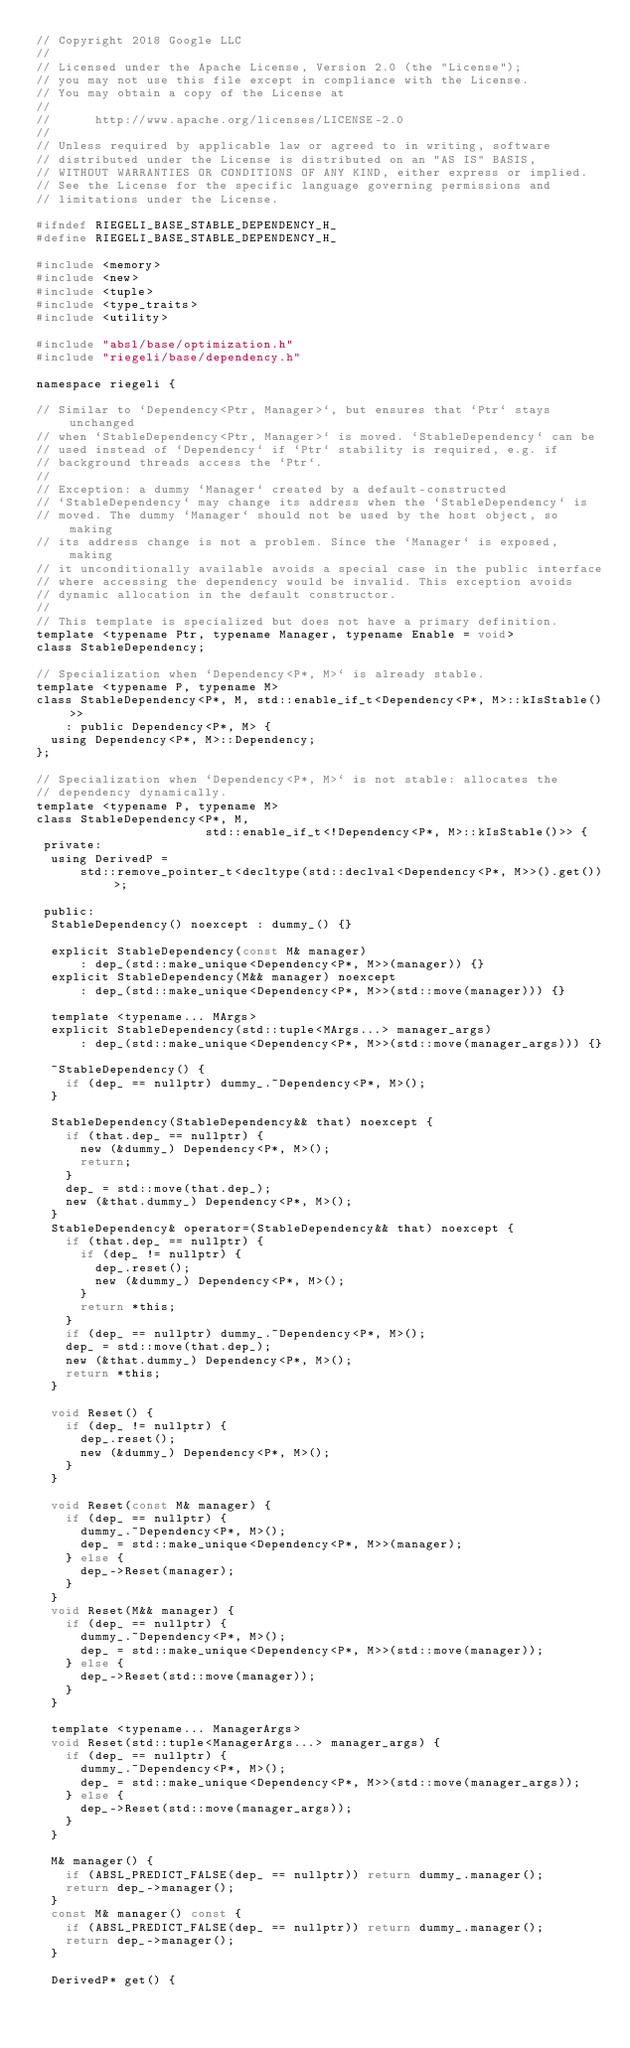Convert code to text. <code><loc_0><loc_0><loc_500><loc_500><_C_>// Copyright 2018 Google LLC
//
// Licensed under the Apache License, Version 2.0 (the "License");
// you may not use this file except in compliance with the License.
// You may obtain a copy of the License at
//
//      http://www.apache.org/licenses/LICENSE-2.0
//
// Unless required by applicable law or agreed to in writing, software
// distributed under the License is distributed on an "AS IS" BASIS,
// WITHOUT WARRANTIES OR CONDITIONS OF ANY KIND, either express or implied.
// See the License for the specific language governing permissions and
// limitations under the License.

#ifndef RIEGELI_BASE_STABLE_DEPENDENCY_H_
#define RIEGELI_BASE_STABLE_DEPENDENCY_H_

#include <memory>
#include <new>
#include <tuple>
#include <type_traits>
#include <utility>

#include "absl/base/optimization.h"
#include "riegeli/base/dependency.h"

namespace riegeli {

// Similar to `Dependency<Ptr, Manager>`, but ensures that `Ptr` stays unchanged
// when `StableDependency<Ptr, Manager>` is moved. `StableDependency` can be
// used instead of `Dependency` if `Ptr` stability is required, e.g. if
// background threads access the `Ptr`.
//
// Exception: a dummy `Manager` created by a default-constructed
// `StableDependency` may change its address when the `StableDependency` is
// moved. The dummy `Manager` should not be used by the host object, so making
// its address change is not a problem. Since the `Manager` is exposed, making
// it unconditionally available avoids a special case in the public interface
// where accessing the dependency would be invalid. This exception avoids
// dynamic allocation in the default constructor.
//
// This template is specialized but does not have a primary definition.
template <typename Ptr, typename Manager, typename Enable = void>
class StableDependency;

// Specialization when `Dependency<P*, M>` is already stable.
template <typename P, typename M>
class StableDependency<P*, M, std::enable_if_t<Dependency<P*, M>::kIsStable()>>
    : public Dependency<P*, M> {
  using Dependency<P*, M>::Dependency;
};

// Specialization when `Dependency<P*, M>` is not stable: allocates the
// dependency dynamically.
template <typename P, typename M>
class StableDependency<P*, M,
                       std::enable_if_t<!Dependency<P*, M>::kIsStable()>> {
 private:
  using DerivedP =
      std::remove_pointer_t<decltype(std::declval<Dependency<P*, M>>().get())>;

 public:
  StableDependency() noexcept : dummy_() {}

  explicit StableDependency(const M& manager)
      : dep_(std::make_unique<Dependency<P*, M>>(manager)) {}
  explicit StableDependency(M&& manager) noexcept
      : dep_(std::make_unique<Dependency<P*, M>>(std::move(manager))) {}

  template <typename... MArgs>
  explicit StableDependency(std::tuple<MArgs...> manager_args)
      : dep_(std::make_unique<Dependency<P*, M>>(std::move(manager_args))) {}

  ~StableDependency() {
    if (dep_ == nullptr) dummy_.~Dependency<P*, M>();
  }

  StableDependency(StableDependency&& that) noexcept {
    if (that.dep_ == nullptr) {
      new (&dummy_) Dependency<P*, M>();
      return;
    }
    dep_ = std::move(that.dep_);
    new (&that.dummy_) Dependency<P*, M>();
  }
  StableDependency& operator=(StableDependency&& that) noexcept {
    if (that.dep_ == nullptr) {
      if (dep_ != nullptr) {
        dep_.reset();
        new (&dummy_) Dependency<P*, M>();
      }
      return *this;
    }
    if (dep_ == nullptr) dummy_.~Dependency<P*, M>();
    dep_ = std::move(that.dep_);
    new (&that.dummy_) Dependency<P*, M>();
    return *this;
  }

  void Reset() {
    if (dep_ != nullptr) {
      dep_.reset();
      new (&dummy_) Dependency<P*, M>();
    }
  }

  void Reset(const M& manager) {
    if (dep_ == nullptr) {
      dummy_.~Dependency<P*, M>();
      dep_ = std::make_unique<Dependency<P*, M>>(manager);
    } else {
      dep_->Reset(manager);
    }
  }
  void Reset(M&& manager) {
    if (dep_ == nullptr) {
      dummy_.~Dependency<P*, M>();
      dep_ = std::make_unique<Dependency<P*, M>>(std::move(manager));
    } else {
      dep_->Reset(std::move(manager));
    }
  }

  template <typename... ManagerArgs>
  void Reset(std::tuple<ManagerArgs...> manager_args) {
    if (dep_ == nullptr) {
      dummy_.~Dependency<P*, M>();
      dep_ = std::make_unique<Dependency<P*, M>>(std::move(manager_args));
    } else {
      dep_->Reset(std::move(manager_args));
    }
  }

  M& manager() {
    if (ABSL_PREDICT_FALSE(dep_ == nullptr)) return dummy_.manager();
    return dep_->manager();
  }
  const M& manager() const {
    if (ABSL_PREDICT_FALSE(dep_ == nullptr)) return dummy_.manager();
    return dep_->manager();
  }

  DerivedP* get() {</code> 